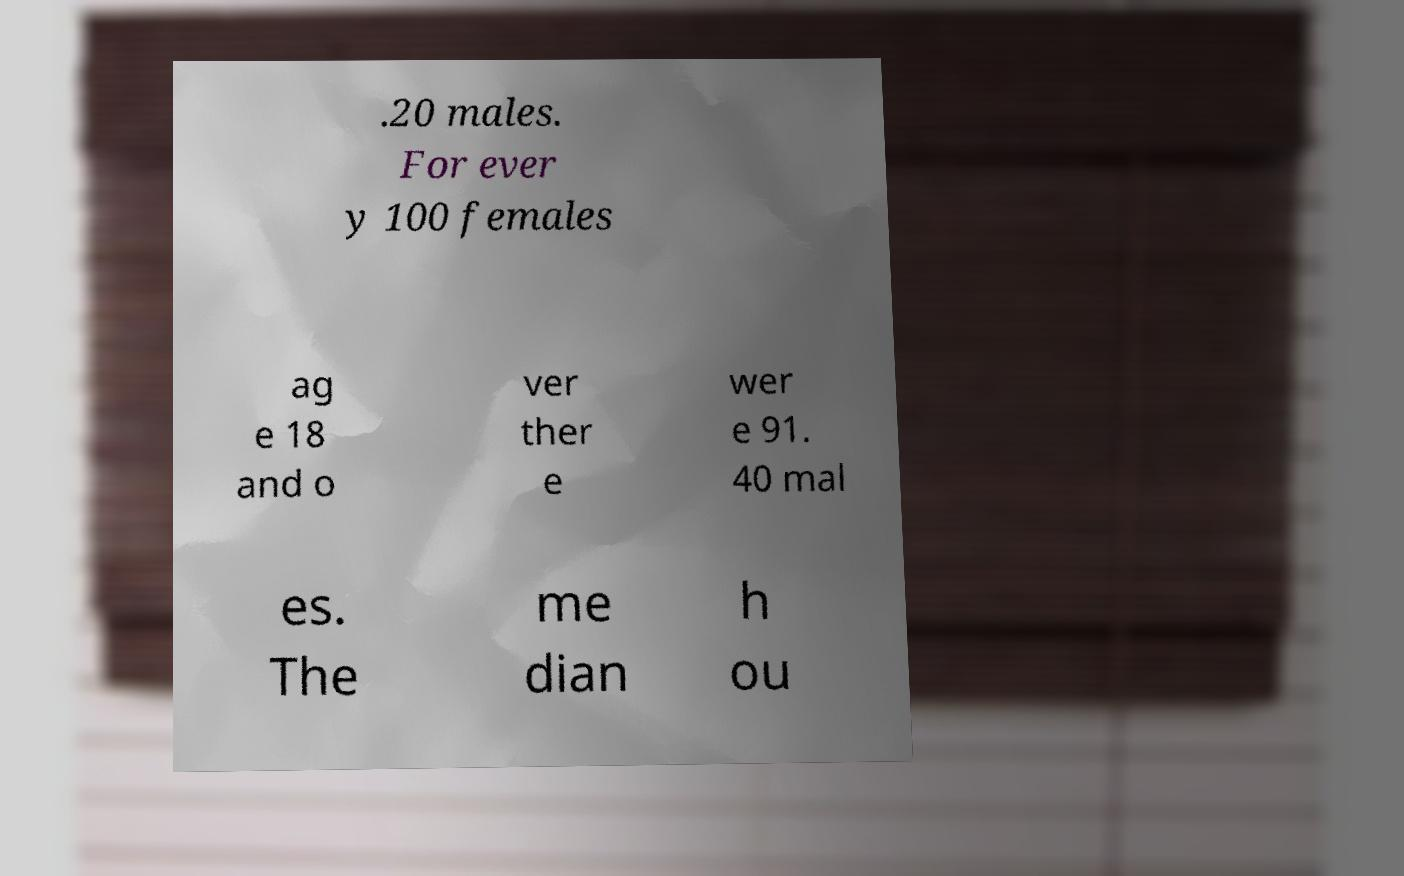I need the written content from this picture converted into text. Can you do that? .20 males. For ever y 100 females ag e 18 and o ver ther e wer e 91. 40 mal es. The me dian h ou 